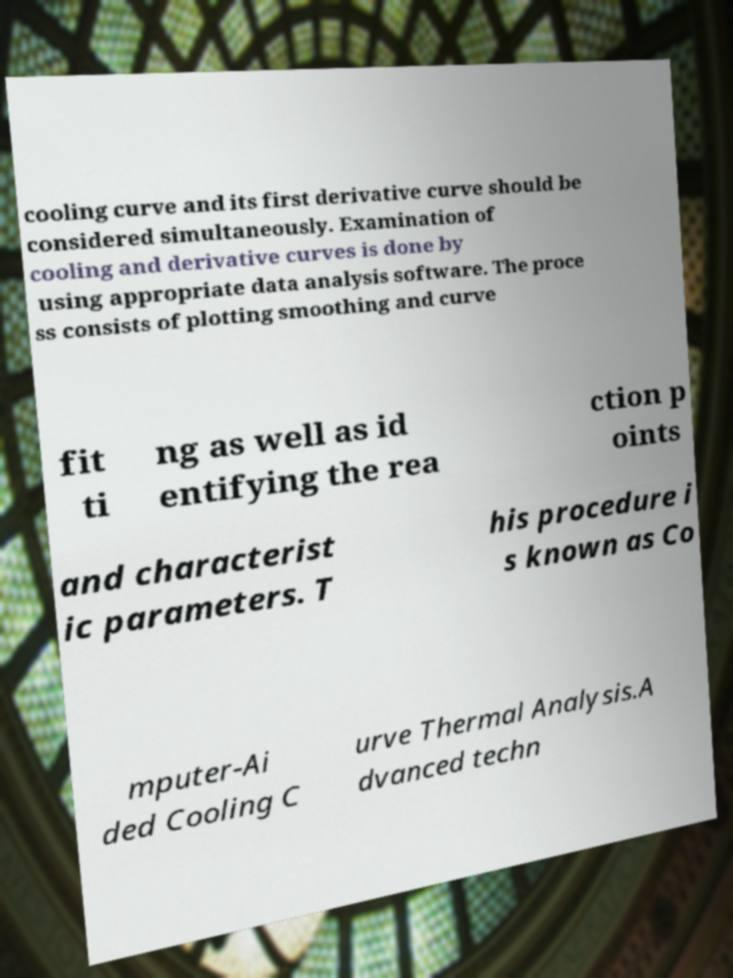For documentation purposes, I need the text within this image transcribed. Could you provide that? cooling curve and its first derivative curve should be considered simultaneously. Examination of cooling and derivative curves is done by using appropriate data analysis software. The proce ss consists of plotting smoothing and curve fit ti ng as well as id entifying the rea ction p oints and characterist ic parameters. T his procedure i s known as Co mputer-Ai ded Cooling C urve Thermal Analysis.A dvanced techn 